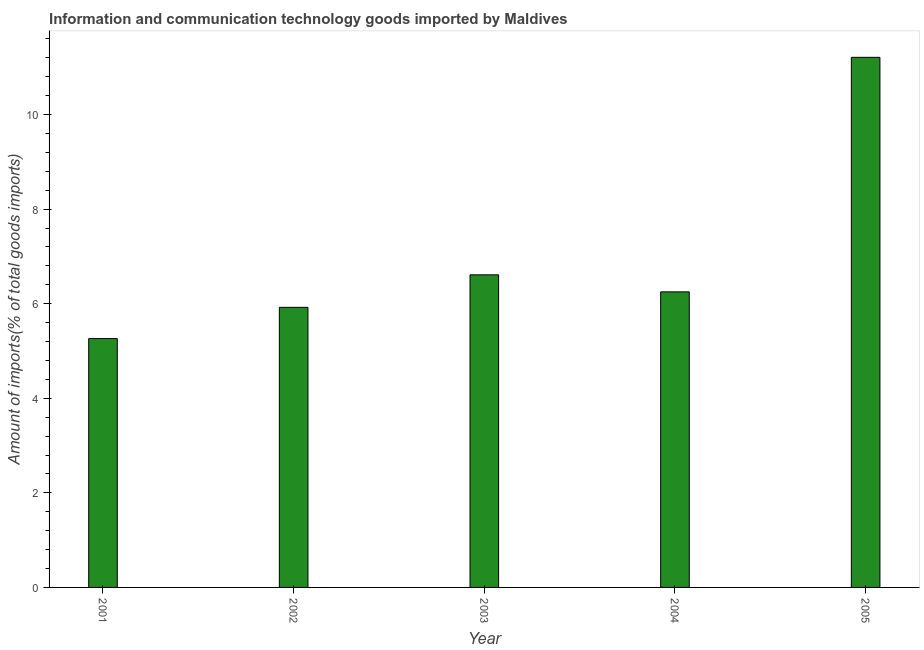Does the graph contain any zero values?
Your response must be concise. No. Does the graph contain grids?
Offer a terse response. No. What is the title of the graph?
Give a very brief answer. Information and communication technology goods imported by Maldives. What is the label or title of the X-axis?
Offer a terse response. Year. What is the label or title of the Y-axis?
Your answer should be compact. Amount of imports(% of total goods imports). What is the amount of ict goods imports in 2002?
Offer a very short reply. 5.92. Across all years, what is the maximum amount of ict goods imports?
Ensure brevity in your answer.  11.21. Across all years, what is the minimum amount of ict goods imports?
Offer a terse response. 5.26. In which year was the amount of ict goods imports maximum?
Provide a succinct answer. 2005. What is the sum of the amount of ict goods imports?
Your answer should be compact. 35.25. What is the difference between the amount of ict goods imports in 2003 and 2005?
Offer a very short reply. -4.6. What is the average amount of ict goods imports per year?
Ensure brevity in your answer.  7.05. What is the median amount of ict goods imports?
Your response must be concise. 6.25. In how many years, is the amount of ict goods imports greater than 3.6 %?
Make the answer very short. 5. Do a majority of the years between 2002 and 2005 (inclusive) have amount of ict goods imports greater than 9.2 %?
Keep it short and to the point. No. What is the ratio of the amount of ict goods imports in 2002 to that in 2003?
Your response must be concise. 0.9. Is the amount of ict goods imports in 2001 less than that in 2003?
Offer a terse response. Yes. What is the difference between the highest and the second highest amount of ict goods imports?
Your response must be concise. 4.6. Is the sum of the amount of ict goods imports in 2004 and 2005 greater than the maximum amount of ict goods imports across all years?
Offer a terse response. Yes. What is the difference between the highest and the lowest amount of ict goods imports?
Provide a succinct answer. 5.95. In how many years, is the amount of ict goods imports greater than the average amount of ict goods imports taken over all years?
Provide a succinct answer. 1. Are all the bars in the graph horizontal?
Give a very brief answer. No. Are the values on the major ticks of Y-axis written in scientific E-notation?
Your response must be concise. No. What is the Amount of imports(% of total goods imports) in 2001?
Keep it short and to the point. 5.26. What is the Amount of imports(% of total goods imports) of 2002?
Your answer should be compact. 5.92. What is the Amount of imports(% of total goods imports) of 2003?
Offer a very short reply. 6.61. What is the Amount of imports(% of total goods imports) in 2004?
Keep it short and to the point. 6.25. What is the Amount of imports(% of total goods imports) in 2005?
Your answer should be very brief. 11.21. What is the difference between the Amount of imports(% of total goods imports) in 2001 and 2002?
Keep it short and to the point. -0.66. What is the difference between the Amount of imports(% of total goods imports) in 2001 and 2003?
Ensure brevity in your answer.  -1.35. What is the difference between the Amount of imports(% of total goods imports) in 2001 and 2004?
Provide a short and direct response. -0.99. What is the difference between the Amount of imports(% of total goods imports) in 2001 and 2005?
Offer a terse response. -5.95. What is the difference between the Amount of imports(% of total goods imports) in 2002 and 2003?
Ensure brevity in your answer.  -0.69. What is the difference between the Amount of imports(% of total goods imports) in 2002 and 2004?
Give a very brief answer. -0.33. What is the difference between the Amount of imports(% of total goods imports) in 2002 and 2005?
Provide a succinct answer. -5.29. What is the difference between the Amount of imports(% of total goods imports) in 2003 and 2004?
Keep it short and to the point. 0.36. What is the difference between the Amount of imports(% of total goods imports) in 2003 and 2005?
Your response must be concise. -4.6. What is the difference between the Amount of imports(% of total goods imports) in 2004 and 2005?
Give a very brief answer. -4.96. What is the ratio of the Amount of imports(% of total goods imports) in 2001 to that in 2002?
Your answer should be compact. 0.89. What is the ratio of the Amount of imports(% of total goods imports) in 2001 to that in 2003?
Ensure brevity in your answer.  0.8. What is the ratio of the Amount of imports(% of total goods imports) in 2001 to that in 2004?
Provide a succinct answer. 0.84. What is the ratio of the Amount of imports(% of total goods imports) in 2001 to that in 2005?
Provide a short and direct response. 0.47. What is the ratio of the Amount of imports(% of total goods imports) in 2002 to that in 2003?
Give a very brief answer. 0.9. What is the ratio of the Amount of imports(% of total goods imports) in 2002 to that in 2004?
Ensure brevity in your answer.  0.95. What is the ratio of the Amount of imports(% of total goods imports) in 2002 to that in 2005?
Your response must be concise. 0.53. What is the ratio of the Amount of imports(% of total goods imports) in 2003 to that in 2004?
Ensure brevity in your answer.  1.06. What is the ratio of the Amount of imports(% of total goods imports) in 2003 to that in 2005?
Your response must be concise. 0.59. What is the ratio of the Amount of imports(% of total goods imports) in 2004 to that in 2005?
Provide a short and direct response. 0.56. 